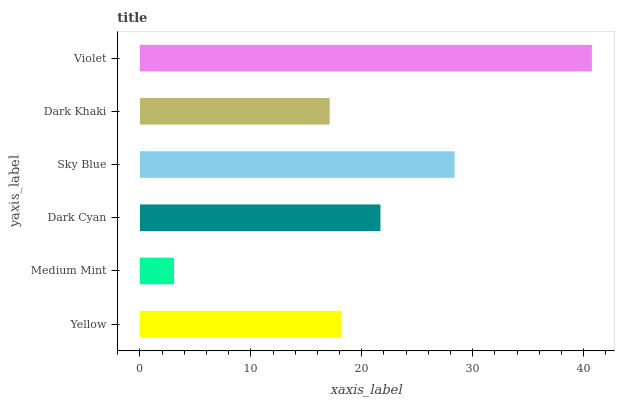Is Medium Mint the minimum?
Answer yes or no. Yes. Is Violet the maximum?
Answer yes or no. Yes. Is Dark Cyan the minimum?
Answer yes or no. No. Is Dark Cyan the maximum?
Answer yes or no. No. Is Dark Cyan greater than Medium Mint?
Answer yes or no. Yes. Is Medium Mint less than Dark Cyan?
Answer yes or no. Yes. Is Medium Mint greater than Dark Cyan?
Answer yes or no. No. Is Dark Cyan less than Medium Mint?
Answer yes or no. No. Is Dark Cyan the high median?
Answer yes or no. Yes. Is Yellow the low median?
Answer yes or no. Yes. Is Violet the high median?
Answer yes or no. No. Is Dark Khaki the low median?
Answer yes or no. No. 